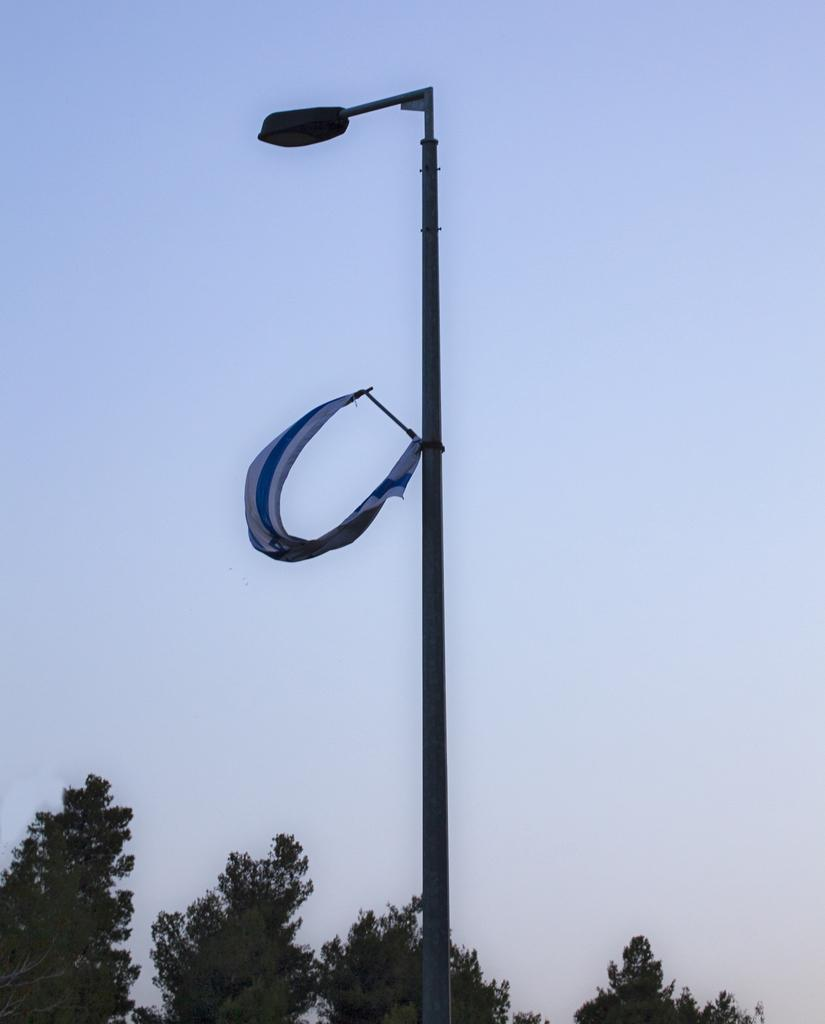What can be seen in the background of the image? The sky is visible in the background of the image. What structure is present in the image? There is a light pole in the image. What is attached to the light pole? There is an object attached to the light pole. What type of vegetation is present at the bottom portion of the image? Trees are present at the bottom portion of the image. What month is depicted in the image? There is no specific month depicted in the image; it only shows the sky, a light pole, an object attached to it, and trees. What note is being played by the trees in the image? There are no musical notes or instruments present in the image; the trees are simply vegetation. 